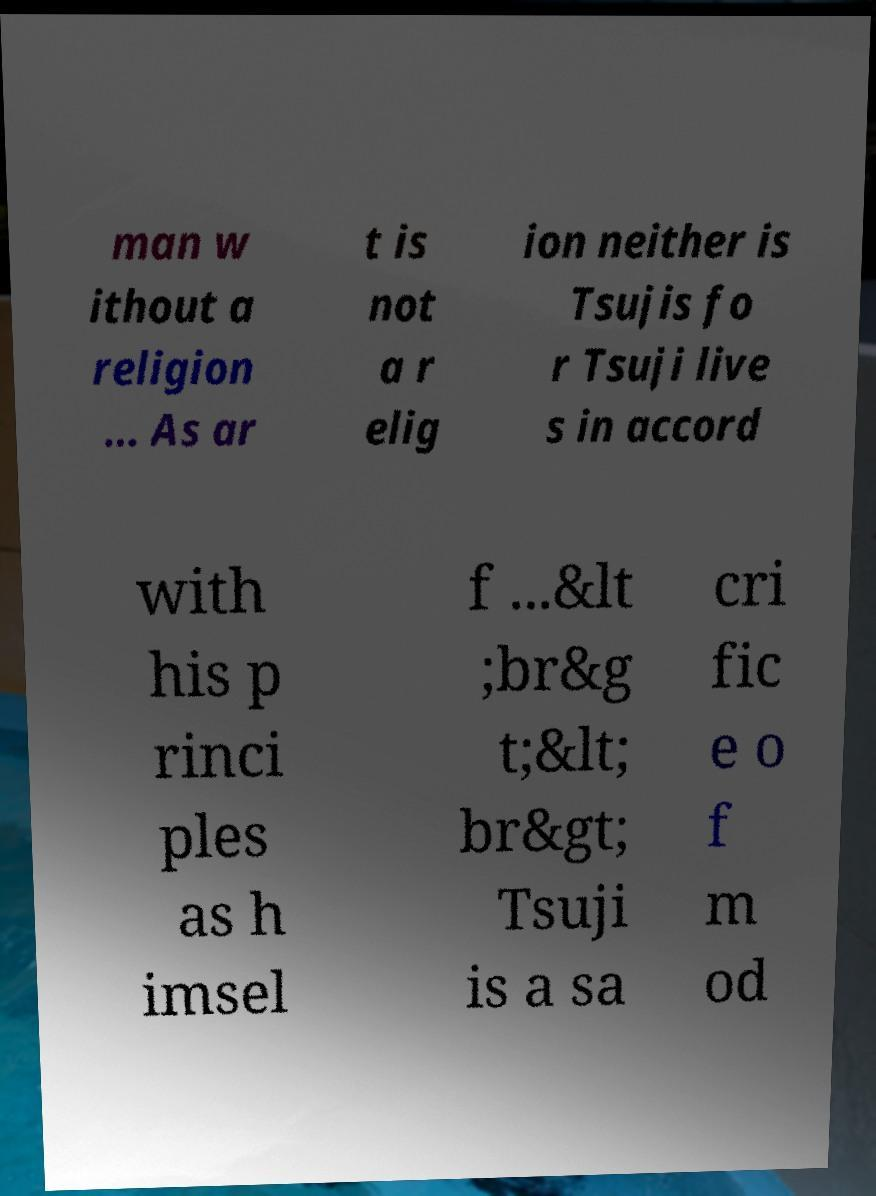What messages or text are displayed in this image? I need them in a readable, typed format. man w ithout a religion ... As ar t is not a r elig ion neither is Tsujis fo r Tsuji live s in accord with his p rinci ples as h imsel f ...&lt ;br&g t;&lt; br&gt; Tsuji is a sa cri fic e o f m od 